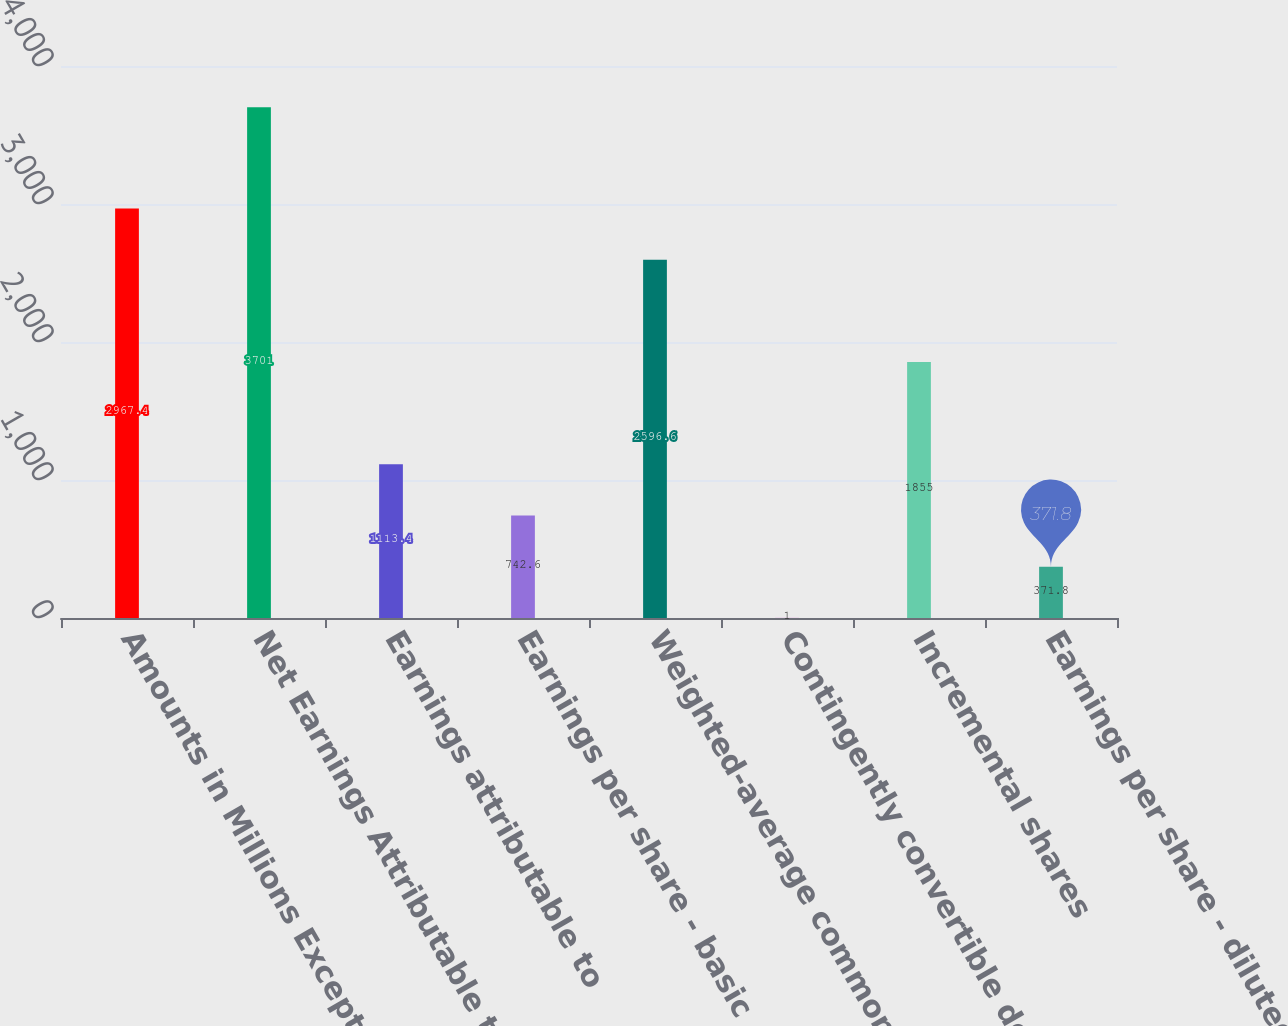Convert chart. <chart><loc_0><loc_0><loc_500><loc_500><bar_chart><fcel>Amounts in Millions Except Per<fcel>Net Earnings Attributable to<fcel>Earnings attributable to<fcel>Earnings per share - basic<fcel>Weighted-average common shares<fcel>Contingently convertible debt<fcel>Incremental shares<fcel>Earnings per share - diluted<nl><fcel>2967.4<fcel>3701<fcel>1113.4<fcel>742.6<fcel>2596.6<fcel>1<fcel>1855<fcel>371.8<nl></chart> 